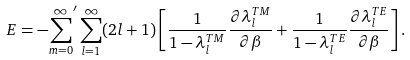<formula> <loc_0><loc_0><loc_500><loc_500>E = - { \sum _ { m = 0 } ^ { \infty } } ^ { \prime } \sum _ { l = 1 } ^ { \infty } ( 2 l + 1 ) \left [ \frac { 1 } { 1 - \lambda _ { l } ^ { T M } } \frac { \partial \lambda _ { l } ^ { T M } } { \partial \beta } + \frac { 1 } { 1 - \lambda _ { l } ^ { T E } } \frac { \partial \lambda _ { l } ^ { T E } } { \partial \beta } \right ] .</formula> 